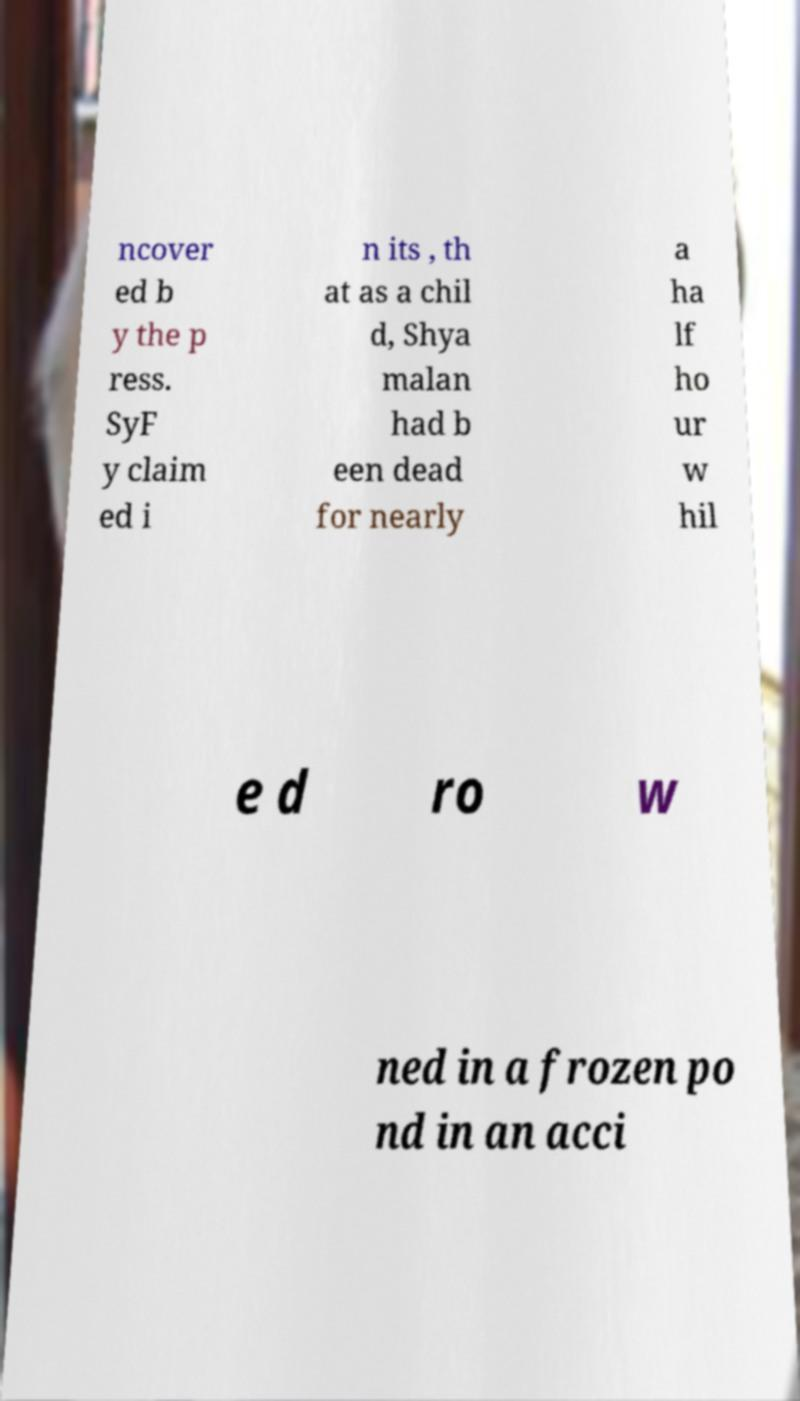Can you accurately transcribe the text from the provided image for me? ncover ed b y the p ress. SyF y claim ed i n its , th at as a chil d, Shya malan had b een dead for nearly a ha lf ho ur w hil e d ro w ned in a frozen po nd in an acci 